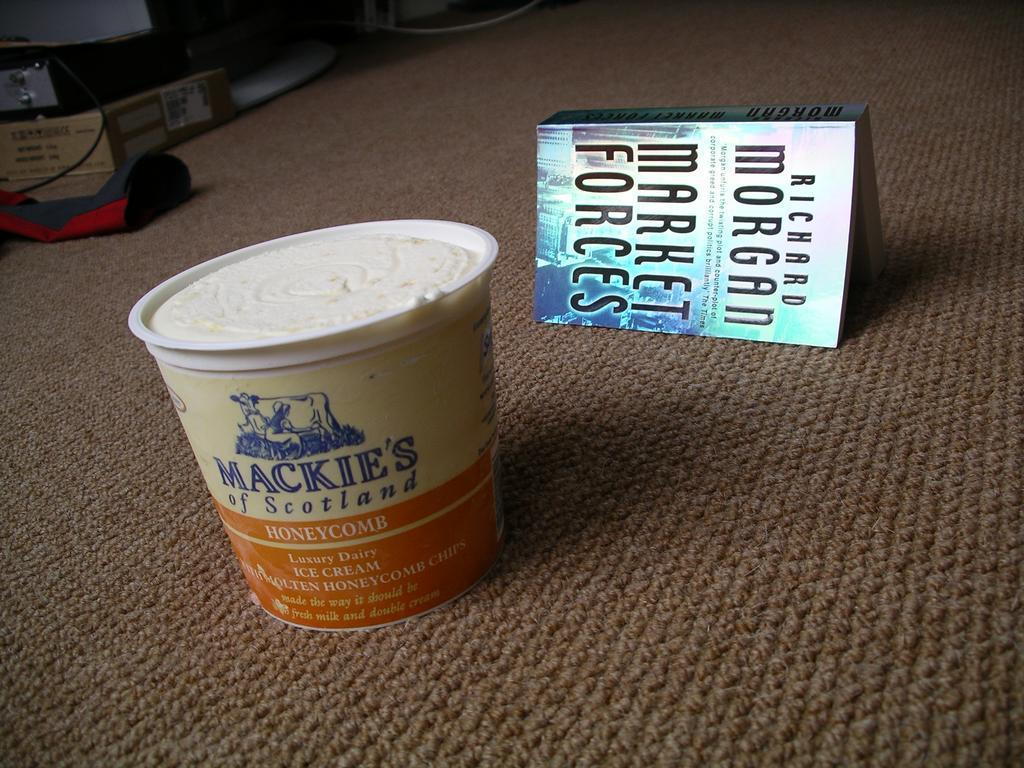What color is the floor in the image? The floor in the image is brown. What objects can be seen on the floor? There is an ice cream box and a book on the floor. What is the purpose of the basketball in the image? There is no basketball present in the image. 